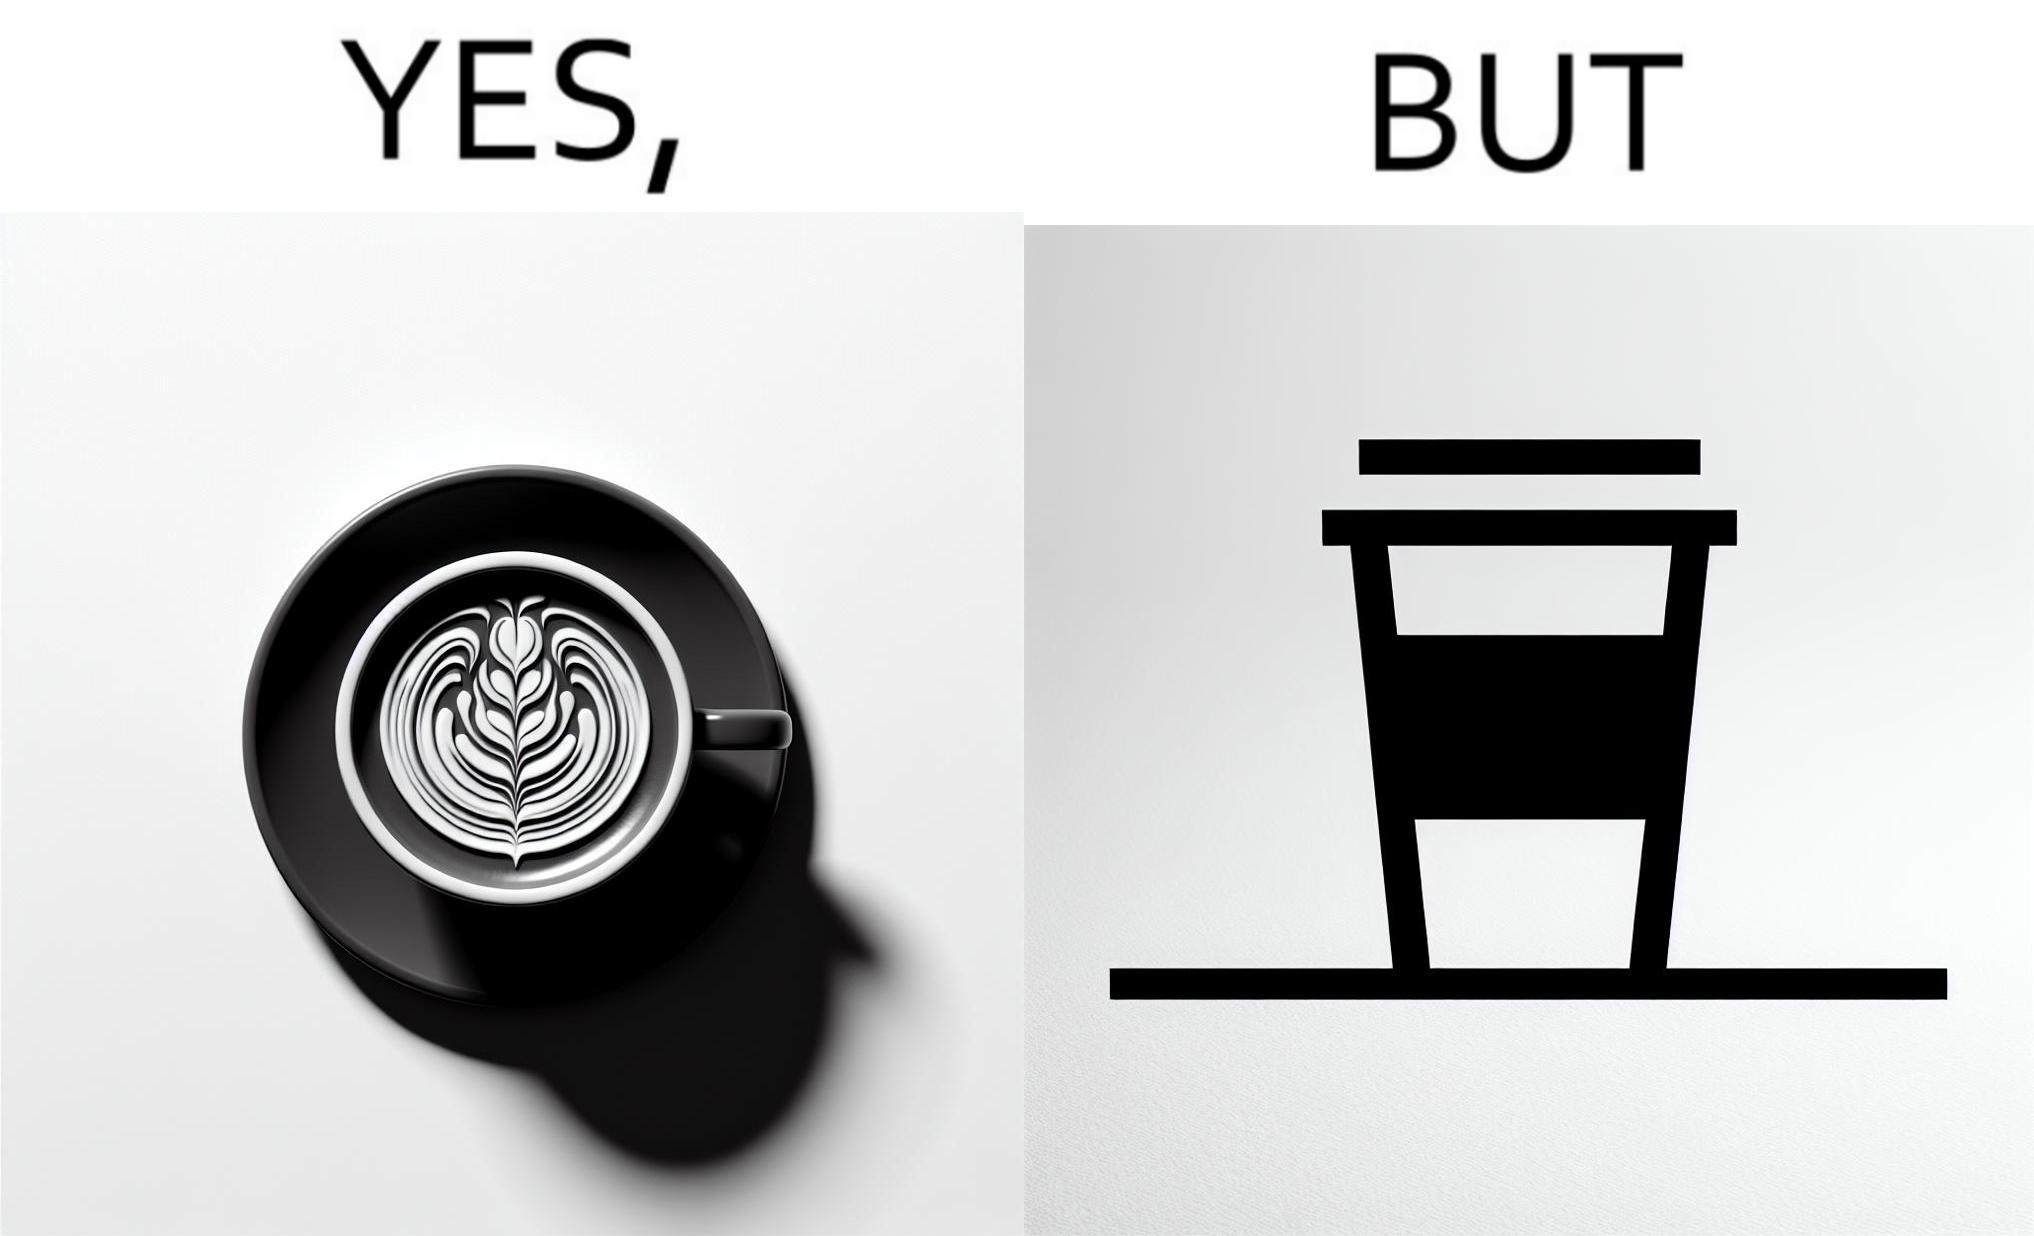Describe the content of this image. The images are funny since it shows how someone has put effort into a cup of coffee to do latte art on it only for it to be invisible after a lid is put on the coffee cup before serving to a customer 